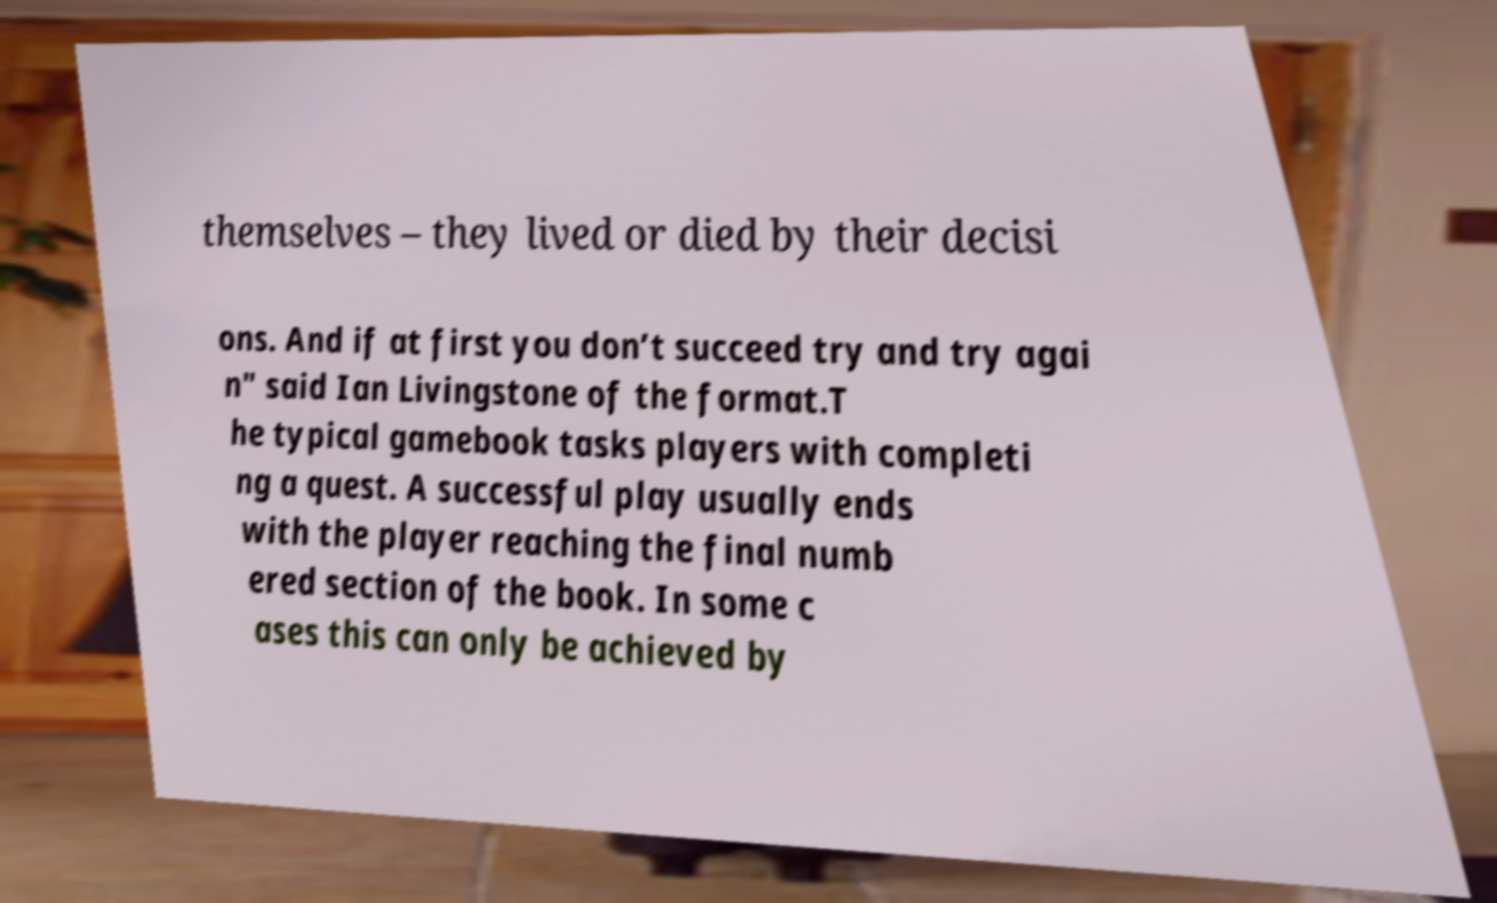I need the written content from this picture converted into text. Can you do that? themselves – they lived or died by their decisi ons. And if at first you don’t succeed try and try agai n" said Ian Livingstone of the format.T he typical gamebook tasks players with completi ng a quest. A successful play usually ends with the player reaching the final numb ered section of the book. In some c ases this can only be achieved by 